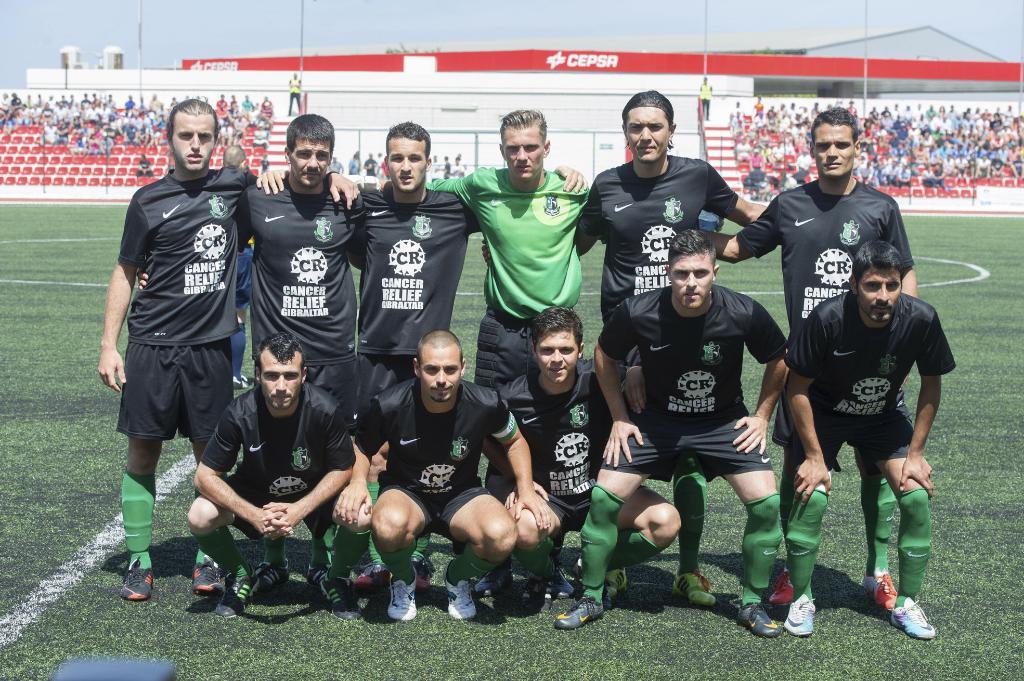What kind of relief is on the jersey?
Ensure brevity in your answer.  Cancer. 